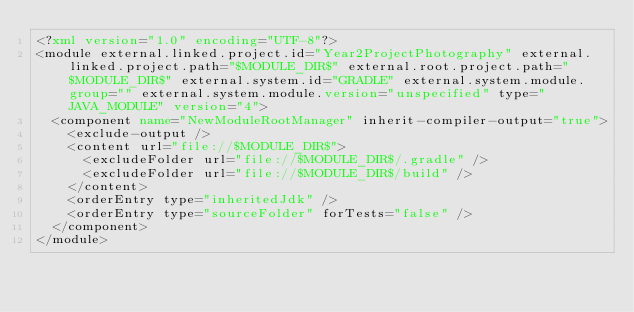Convert code to text. <code><loc_0><loc_0><loc_500><loc_500><_XML_><?xml version="1.0" encoding="UTF-8"?>
<module external.linked.project.id="Year2ProjectPhotography" external.linked.project.path="$MODULE_DIR$" external.root.project.path="$MODULE_DIR$" external.system.id="GRADLE" external.system.module.group="" external.system.module.version="unspecified" type="JAVA_MODULE" version="4">
  <component name="NewModuleRootManager" inherit-compiler-output="true">
    <exclude-output />
    <content url="file://$MODULE_DIR$">
      <excludeFolder url="file://$MODULE_DIR$/.gradle" />
      <excludeFolder url="file://$MODULE_DIR$/build" />
    </content>
    <orderEntry type="inheritedJdk" />
    <orderEntry type="sourceFolder" forTests="false" />
  </component>
</module></code> 